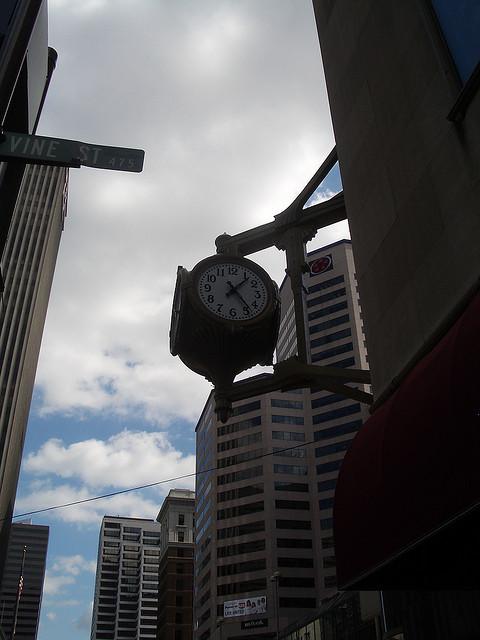Is it dark?
Be succinct. No. What time is it on the clock?
Quick response, please. 1:25. Is the time correct?
Write a very short answer. Yes. 